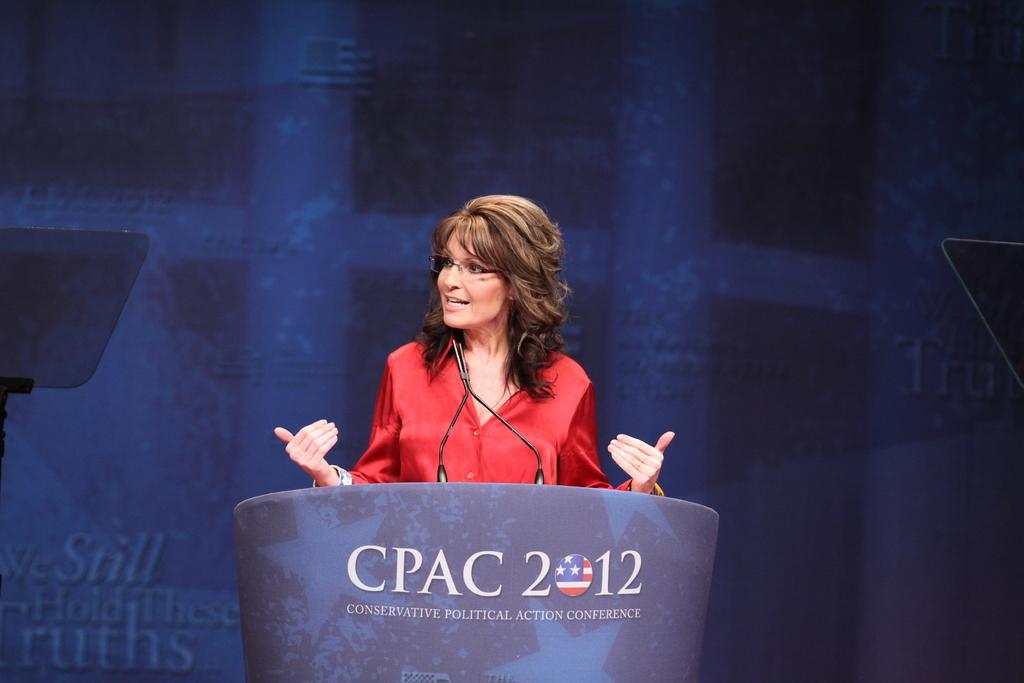What is the main object in the image? There is a podium in the image. What is on the podium? The podium has a microphone. Who is present in the image? There is a woman in the image. Where is the woman located in the image? The woman is in the middle of the image. What is the woman doing? The woman is talking. What is the woman wearing? The woman is wearing a red dress. Can you see any bubbles floating around the woman in the image? There are no bubbles present in the image. What type of watch is the woman wearing in the image? The woman is not wearing a watch in the image. 